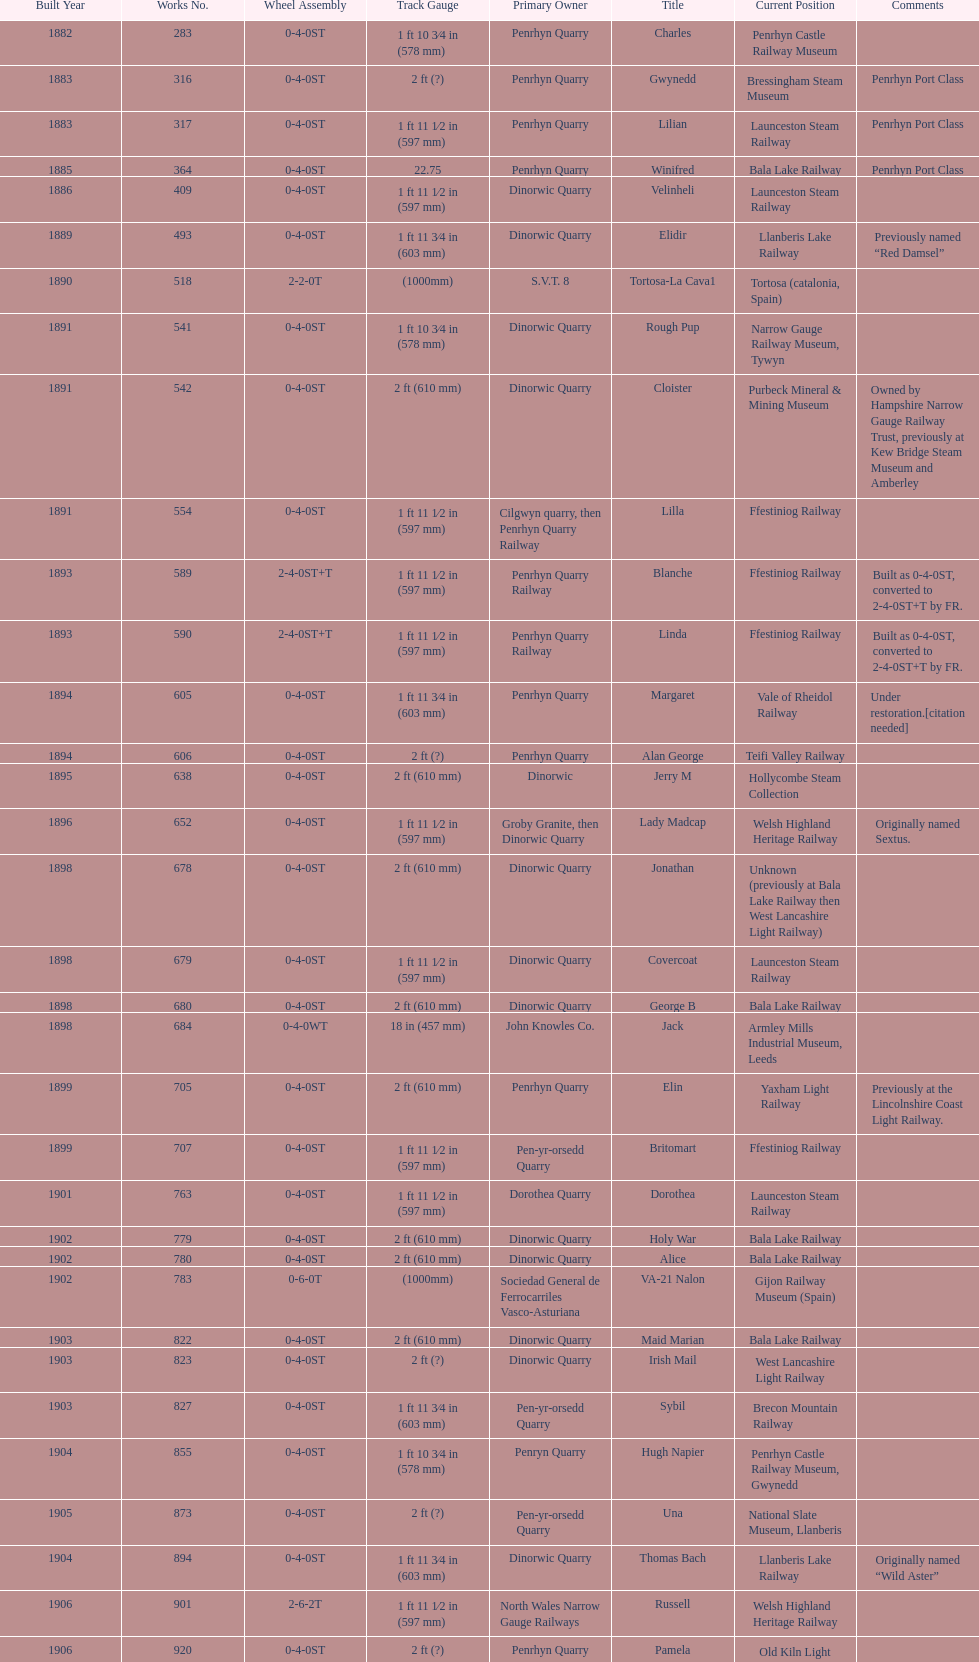What is the difference in gauge between works numbers 541 and 542? 32 mm. 